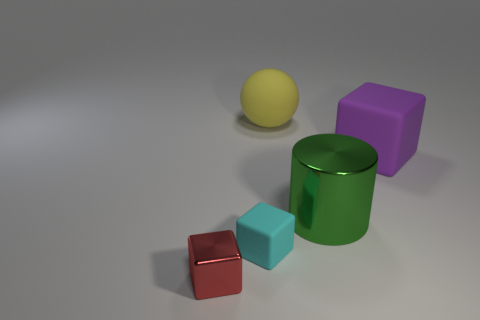Subtract all big purple matte cubes. How many cubes are left? 2 Add 1 big red metallic objects. How many objects exist? 6 Subtract all large green matte spheres. Subtract all big green cylinders. How many objects are left? 4 Add 2 cyan matte blocks. How many cyan matte blocks are left? 3 Add 5 cyan things. How many cyan things exist? 6 Subtract 0 purple cylinders. How many objects are left? 5 Subtract all cylinders. How many objects are left? 4 Subtract all blue blocks. Subtract all purple balls. How many blocks are left? 3 